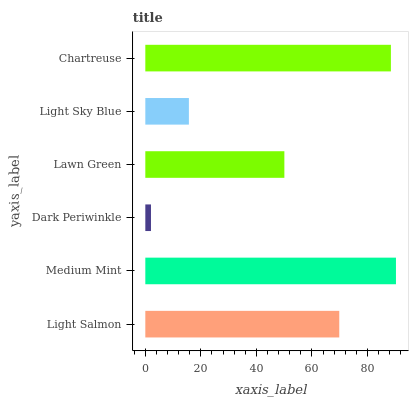Is Dark Periwinkle the minimum?
Answer yes or no. Yes. Is Medium Mint the maximum?
Answer yes or no. Yes. Is Medium Mint the minimum?
Answer yes or no. No. Is Dark Periwinkle the maximum?
Answer yes or no. No. Is Medium Mint greater than Dark Periwinkle?
Answer yes or no. Yes. Is Dark Periwinkle less than Medium Mint?
Answer yes or no. Yes. Is Dark Periwinkle greater than Medium Mint?
Answer yes or no. No. Is Medium Mint less than Dark Periwinkle?
Answer yes or no. No. Is Light Salmon the high median?
Answer yes or no. Yes. Is Lawn Green the low median?
Answer yes or no. Yes. Is Chartreuse the high median?
Answer yes or no. No. Is Medium Mint the low median?
Answer yes or no. No. 